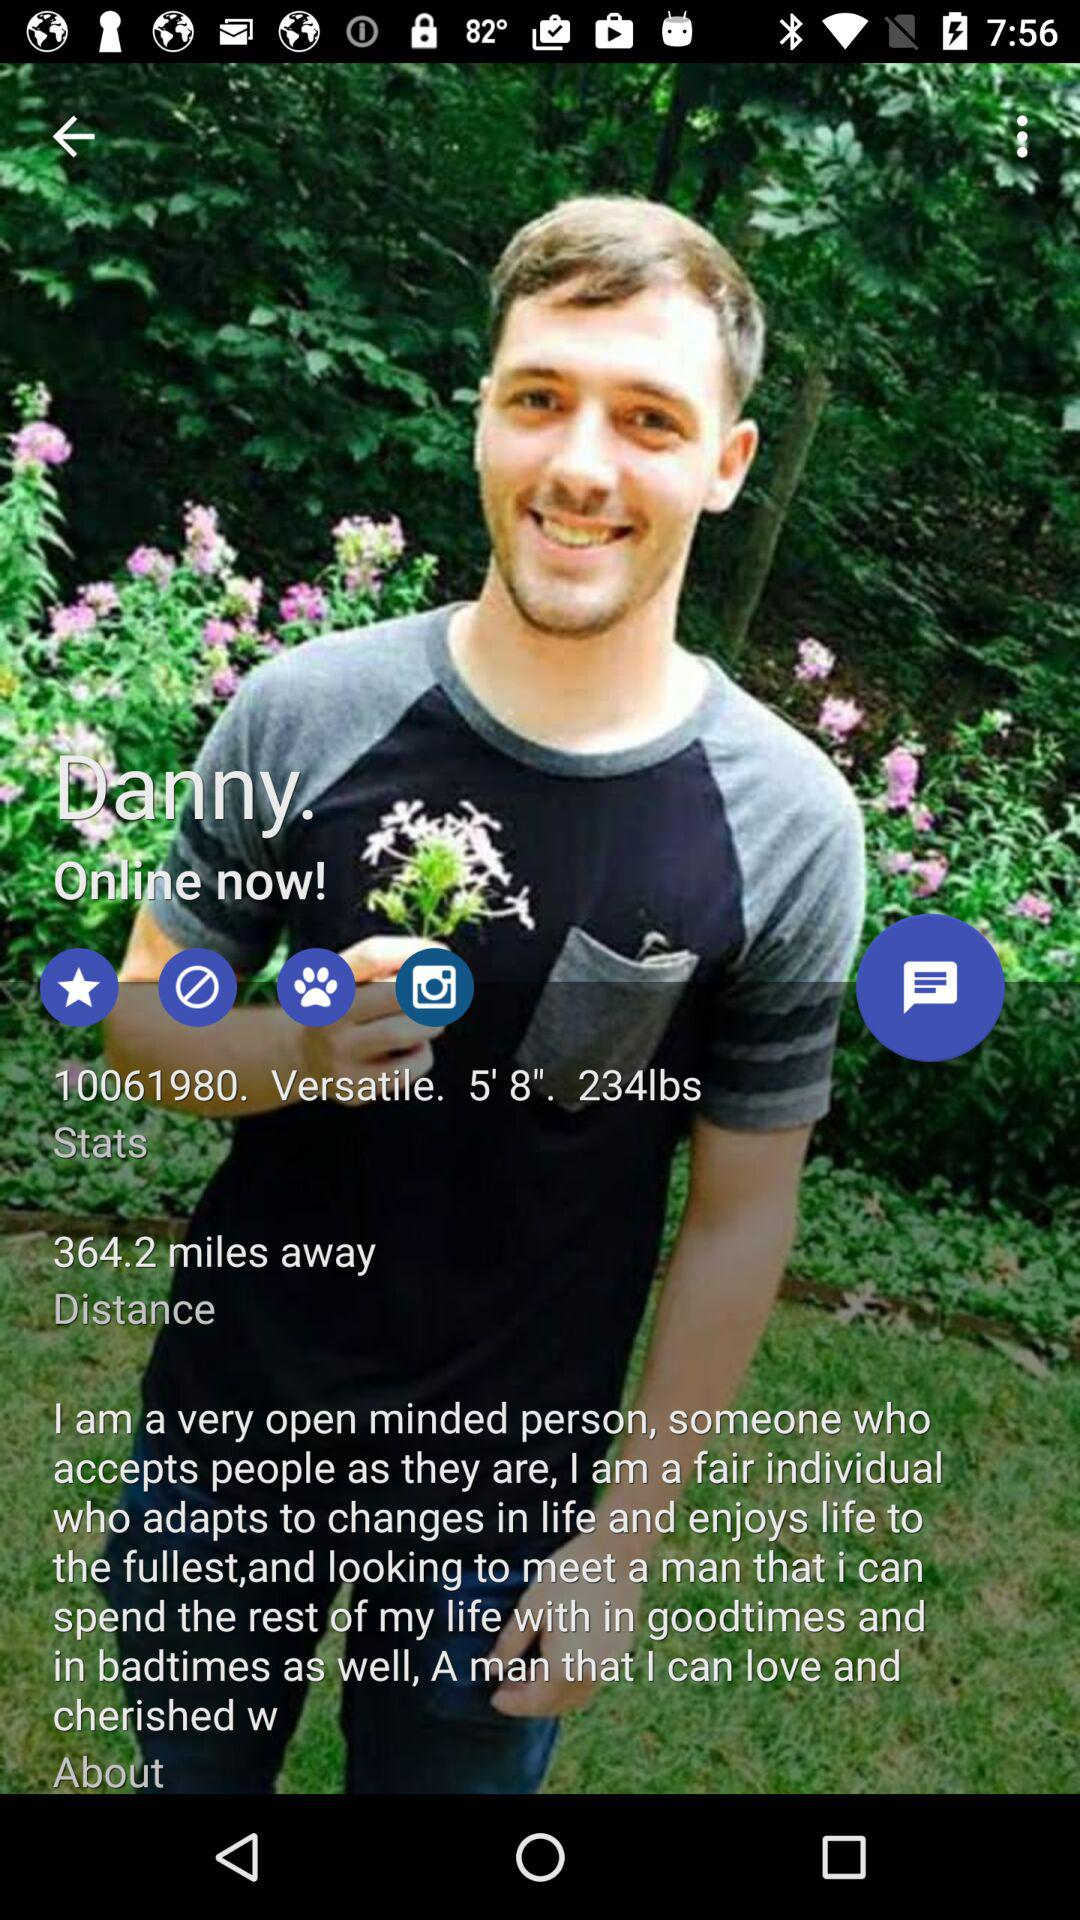What is the status of Danny? The status of Danny is "Online". 